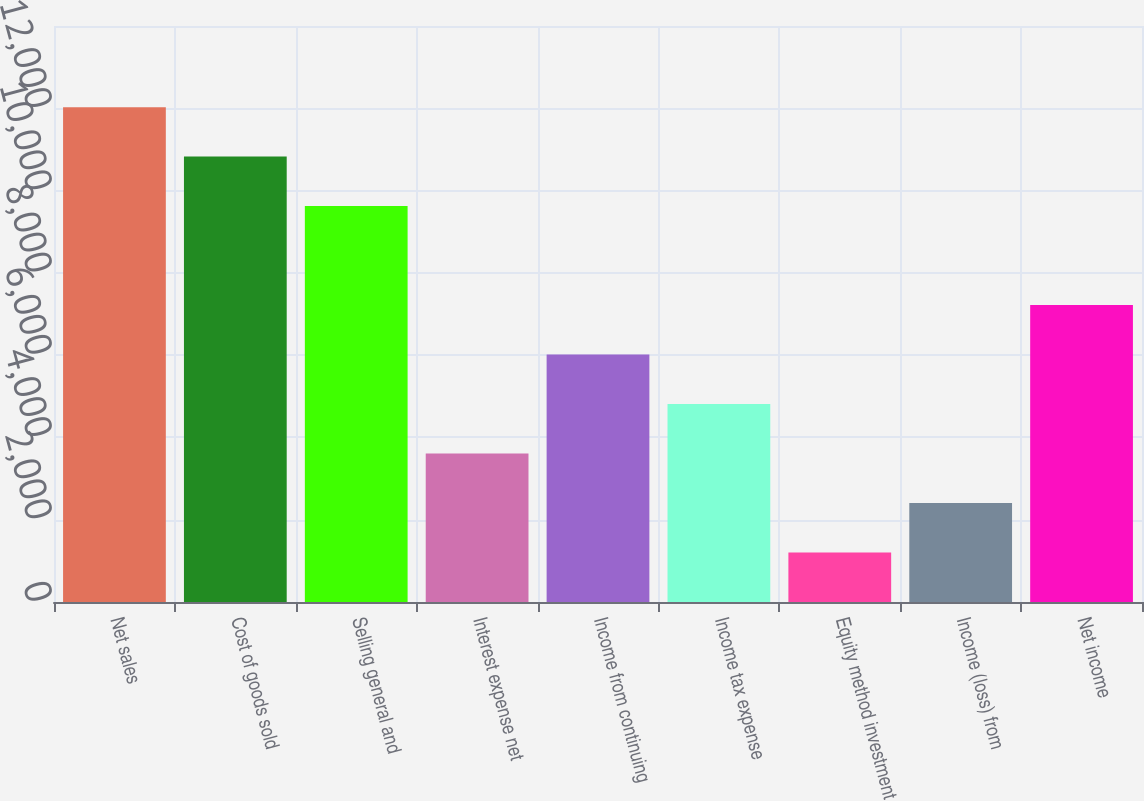Convert chart. <chart><loc_0><loc_0><loc_500><loc_500><bar_chart><fcel>Net sales<fcel>Cost of goods sold<fcel>Selling general and<fcel>Interest expense net<fcel>Income from continuing<fcel>Income tax expense<fcel>Equity method investment<fcel>Income (loss) from<fcel>Net income<nl><fcel>12028.2<fcel>10825.4<fcel>9622.56<fcel>3608.56<fcel>6014.16<fcel>4811.36<fcel>1202.96<fcel>2405.76<fcel>7216.96<nl></chart> 